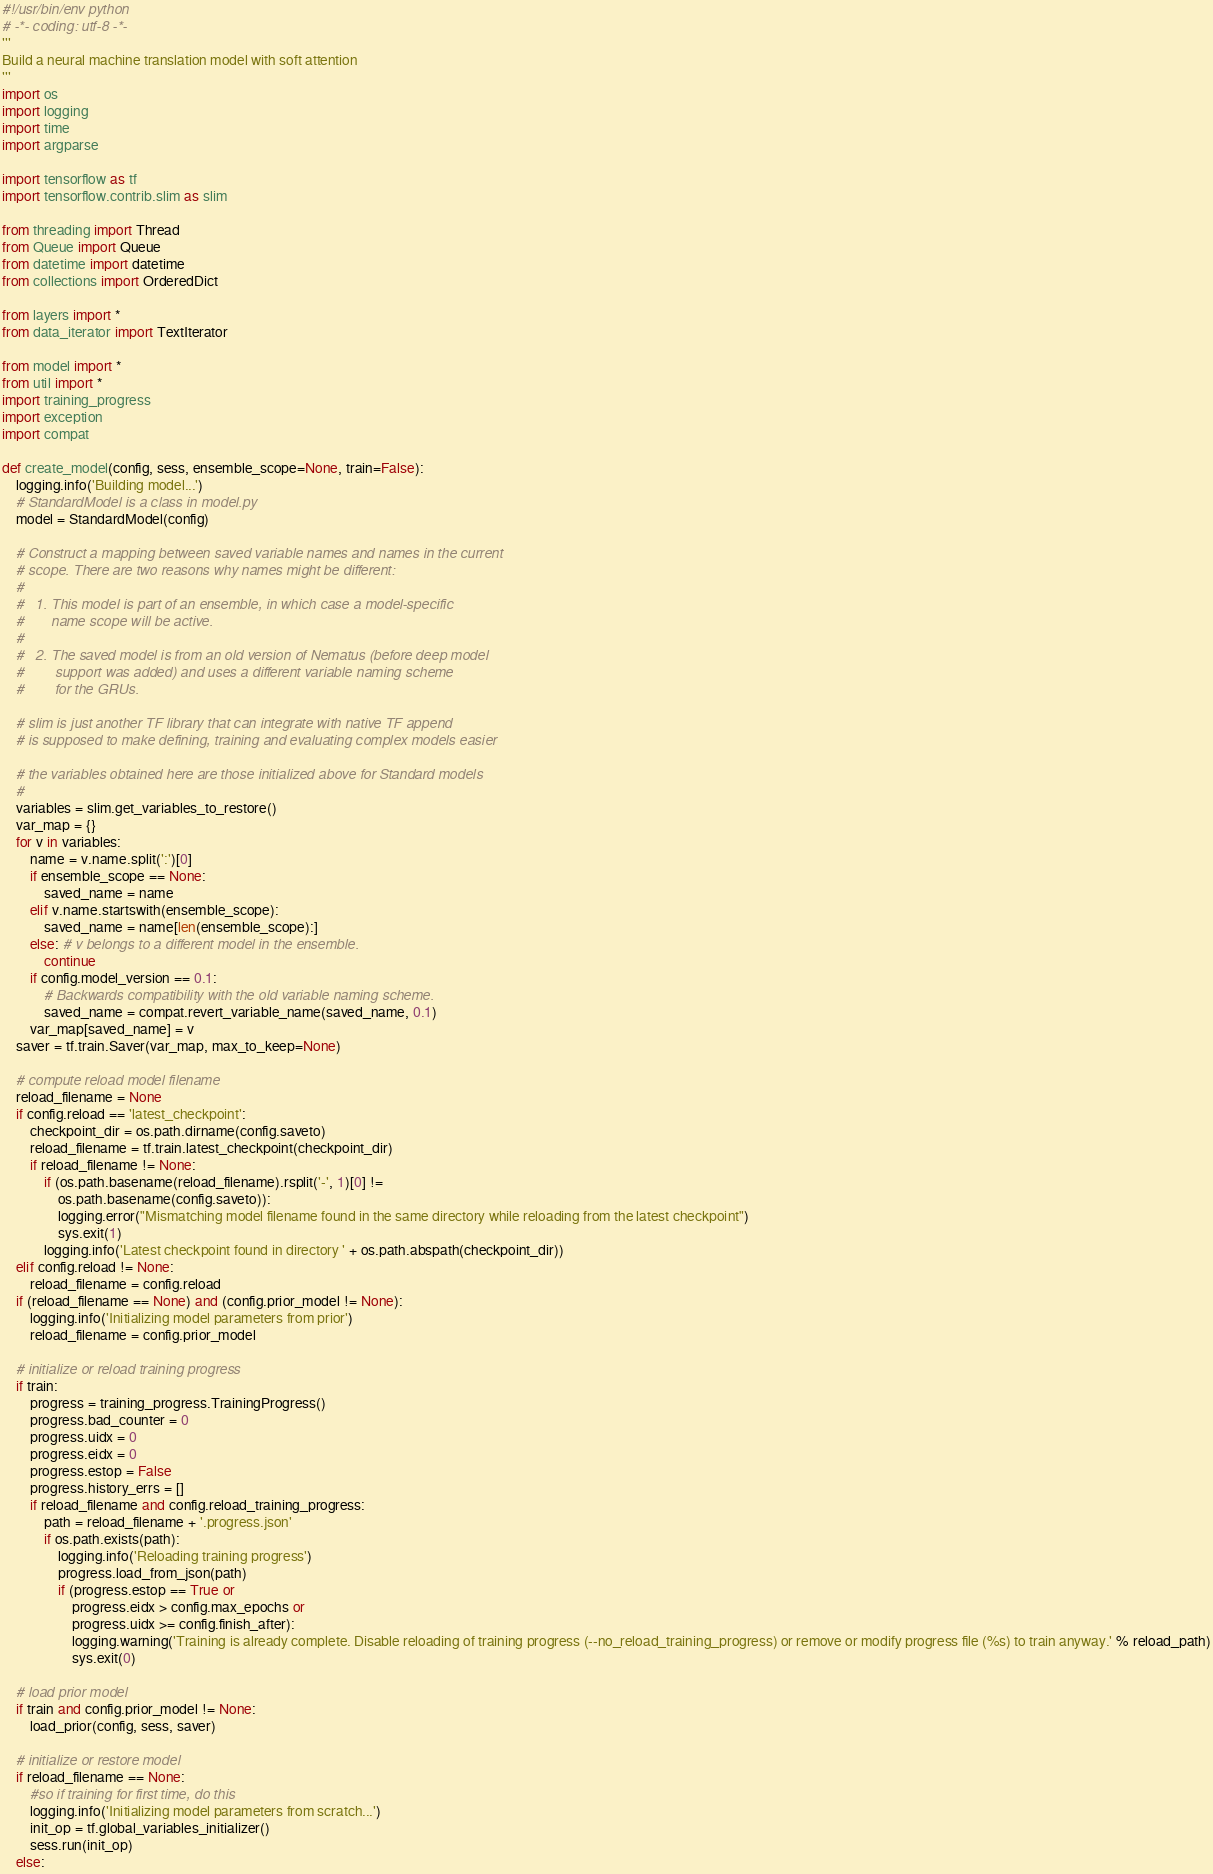<code> <loc_0><loc_0><loc_500><loc_500><_Python_>#!/usr/bin/env python
# -*- coding: utf-8 -*-
'''
Build a neural machine translation model with soft attention
'''
import os
import logging
import time
import argparse

import tensorflow as tf
import tensorflow.contrib.slim as slim

from threading import Thread
from Queue import Queue
from datetime import datetime
from collections import OrderedDict

from layers import *
from data_iterator import TextIterator

from model import *
from util import *
import training_progress
import exception
import compat

def create_model(config, sess, ensemble_scope=None, train=False):
    logging.info('Building model...')
    # StandardModel is a class in model.py
    model = StandardModel(config)

    # Construct a mapping between saved variable names and names in the current
    # scope. There are two reasons why names might be different:
    #
    #   1. This model is part of an ensemble, in which case a model-specific
    #       name scope will be active.
    #
    #   2. The saved model is from an old version of Nematus (before deep model
    #        support was added) and uses a different variable naming scheme
    #        for the GRUs.

    # slim is just another TF library that can integrate with native TF append
    # is supposed to make defining, training and evaluating complex models easier

    # the variables obtained here are those initialized above for Standard models
    #
    variables = slim.get_variables_to_restore()
    var_map = {}
    for v in variables:
        name = v.name.split(':')[0]
        if ensemble_scope == None:
            saved_name = name
        elif v.name.startswith(ensemble_scope):
            saved_name = name[len(ensemble_scope):]
        else: # v belongs to a different model in the ensemble.
            continue
        if config.model_version == 0.1:
            # Backwards compatibility with the old variable naming scheme.
            saved_name = compat.revert_variable_name(saved_name, 0.1)
        var_map[saved_name] = v
    saver = tf.train.Saver(var_map, max_to_keep=None)

    # compute reload model filename
    reload_filename = None
    if config.reload == 'latest_checkpoint':
        checkpoint_dir = os.path.dirname(config.saveto)
        reload_filename = tf.train.latest_checkpoint(checkpoint_dir)
        if reload_filename != None:
            if (os.path.basename(reload_filename).rsplit('-', 1)[0] !=
                os.path.basename(config.saveto)):
                logging.error("Mismatching model filename found in the same directory while reloading from the latest checkpoint")
                sys.exit(1)
            logging.info('Latest checkpoint found in directory ' + os.path.abspath(checkpoint_dir))
    elif config.reload != None:
        reload_filename = config.reload
    if (reload_filename == None) and (config.prior_model != None):
        logging.info('Initializing model parameters from prior')
        reload_filename = config.prior_model

    # initialize or reload training progress
    if train:
        progress = training_progress.TrainingProgress()
        progress.bad_counter = 0
        progress.uidx = 0
        progress.eidx = 0
        progress.estop = False
        progress.history_errs = []
        if reload_filename and config.reload_training_progress:
            path = reload_filename + '.progress.json'
            if os.path.exists(path):
                logging.info('Reloading training progress')
                progress.load_from_json(path)
                if (progress.estop == True or
                    progress.eidx > config.max_epochs or
                    progress.uidx >= config.finish_after):
                    logging.warning('Training is already complete. Disable reloading of training progress (--no_reload_training_progress) or remove or modify progress file (%s) to train anyway.' % reload_path)
                    sys.exit(0)

    # load prior model
    if train and config.prior_model != None:
        load_prior(config, sess, saver)

    # initialize or restore model
    if reload_filename == None:
        #so if training for first time, do this
        logging.info('Initializing model parameters from scratch...')
        init_op = tf.global_variables_initializer()
        sess.run(init_op)
    else:</code> 